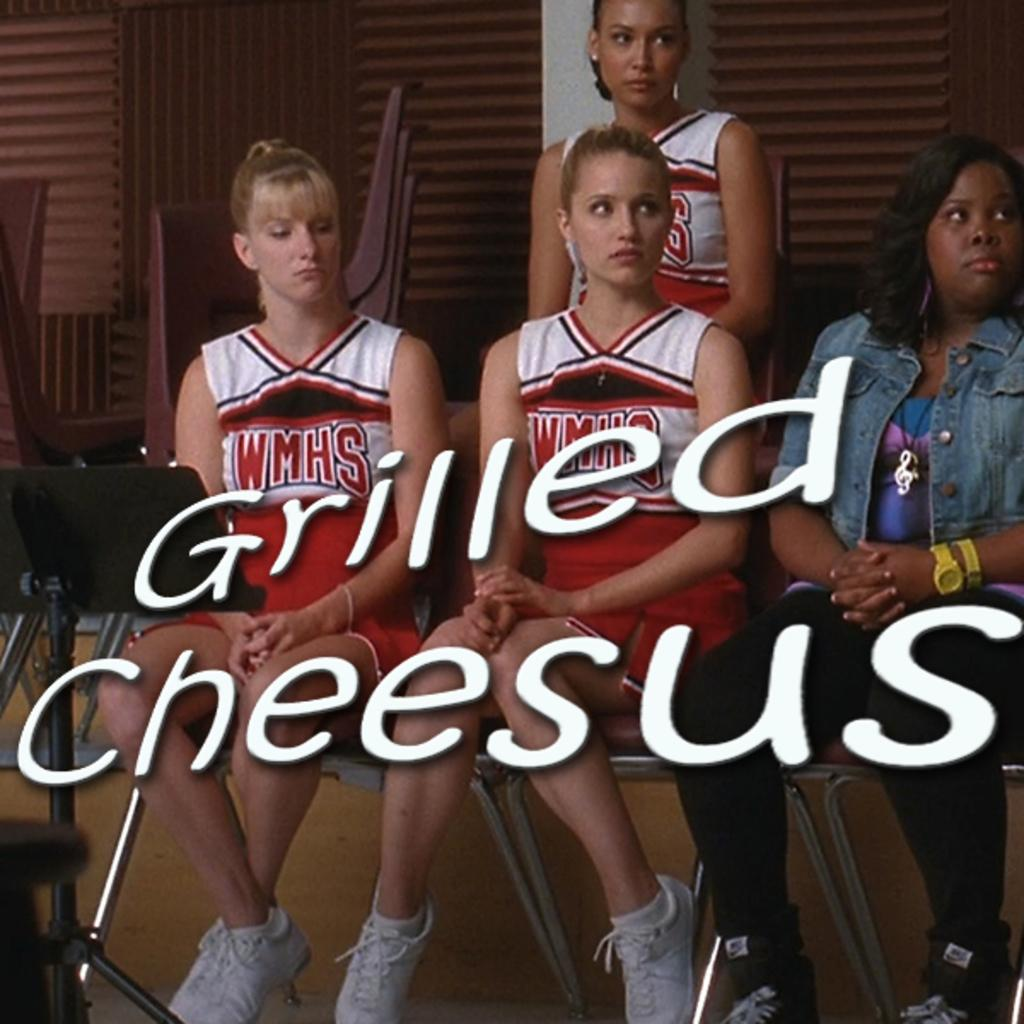<image>
Describe the image concisely. The name over the picture says Grilled Cheesus 